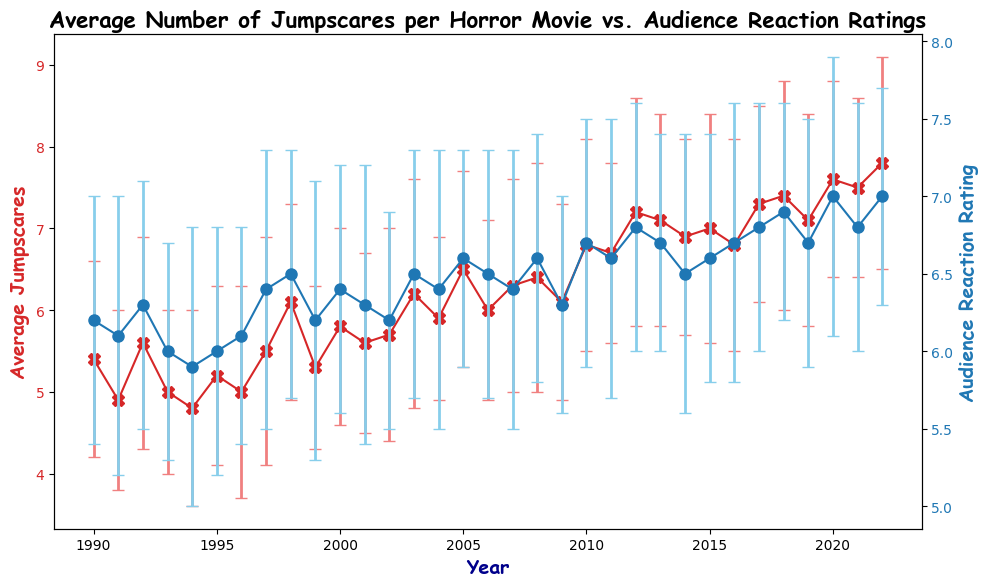What's the average number of jumpscares in 1995 and 2005? To find the average of the jumpscares in 1995 and 2005, we add the averages for these years and divide by 2. For 1995, it's 5.2. For 2005, it's 6.5. Adding these numbers gives us 11.7, so the average is 11.7/2 = 5.85.
Answer: 5.85 Which year had the highest audience reaction rating? Looking at the blue error bars, the highest audience reaction rating is in 2020 and 2022, each has a rating of 7.0.
Answer: 2020, 2022 What is the difference in the average number of jumpscares between 2000 and 2010? The average number of jumpscares in 2000 is 5.8, and in 2010, it is 6.8. The difference is calculated by subtracting the 2000 value from the 2010 value: 6.8 - 5.8 = 1.0.
Answer: 1.0 In which year did the average jumpscares and audience reaction ratings both increase compared to the previous year? We need to check years where both red (jumpscares) and blue (audience reaction ratings) error bars show an increase from the previous year. In 2017, the jumpscares increased to 7.3 from 6.8 in 2016 and the audience reaction rating increased to 6.8 from 6.7 in 2016.
Answer: 2017 What is the trend of the average jumpscares from 2018 to 2022? By observing the red error bars from 2018 to 2022, we can see an increasing trend. The values are 7.4, 7.1, 7.6, 7.5, and 7.8, respectively.
Answer: Increasing Compare the audience reaction ratings in 2003 and 2010. Which one is higher? We need to compare the ratings in 2003 and 2010 by looking at the blue error bars. In 2003, the rating is 6.5, and in 2010, it is 6.7. Thus, 2010 has the higher audience reaction rating.
Answer: 2010 Are the standard deviations for jumpscares in 1992 and 2004 the same? We look at the error bars representing the standard deviations above and below the average values. In 1992, the standard deviation for jumpscares is 1.3, and in 2004, it is 1.0. Hence, they are not the same.
Answer: No 